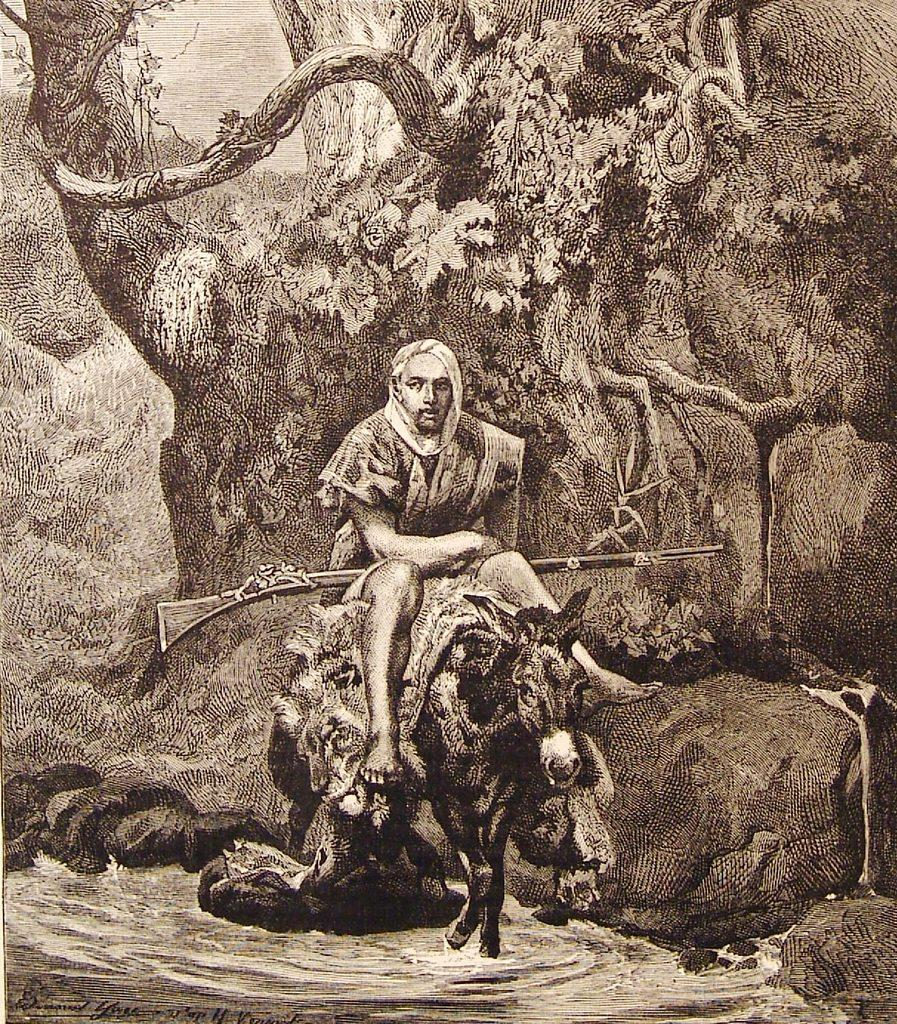What is the main subject of the image? There is a painting in the image. What is happening in the painting? A person is sitting on a donkey in the painting. Where is the donkey located? The donkey is in the water. What can be seen in the background of the painting? There are rocks and trees in the background of the image. How many oranges are being sold by the person sitting on the donkey in the image? There are no oranges present in the image; the person is sitting on a donkey in the water. What type of business does the person sitting on the donkey in the image operate? There is no indication of a business in the image; it simply shows a person sitting on a donkey in the water. 